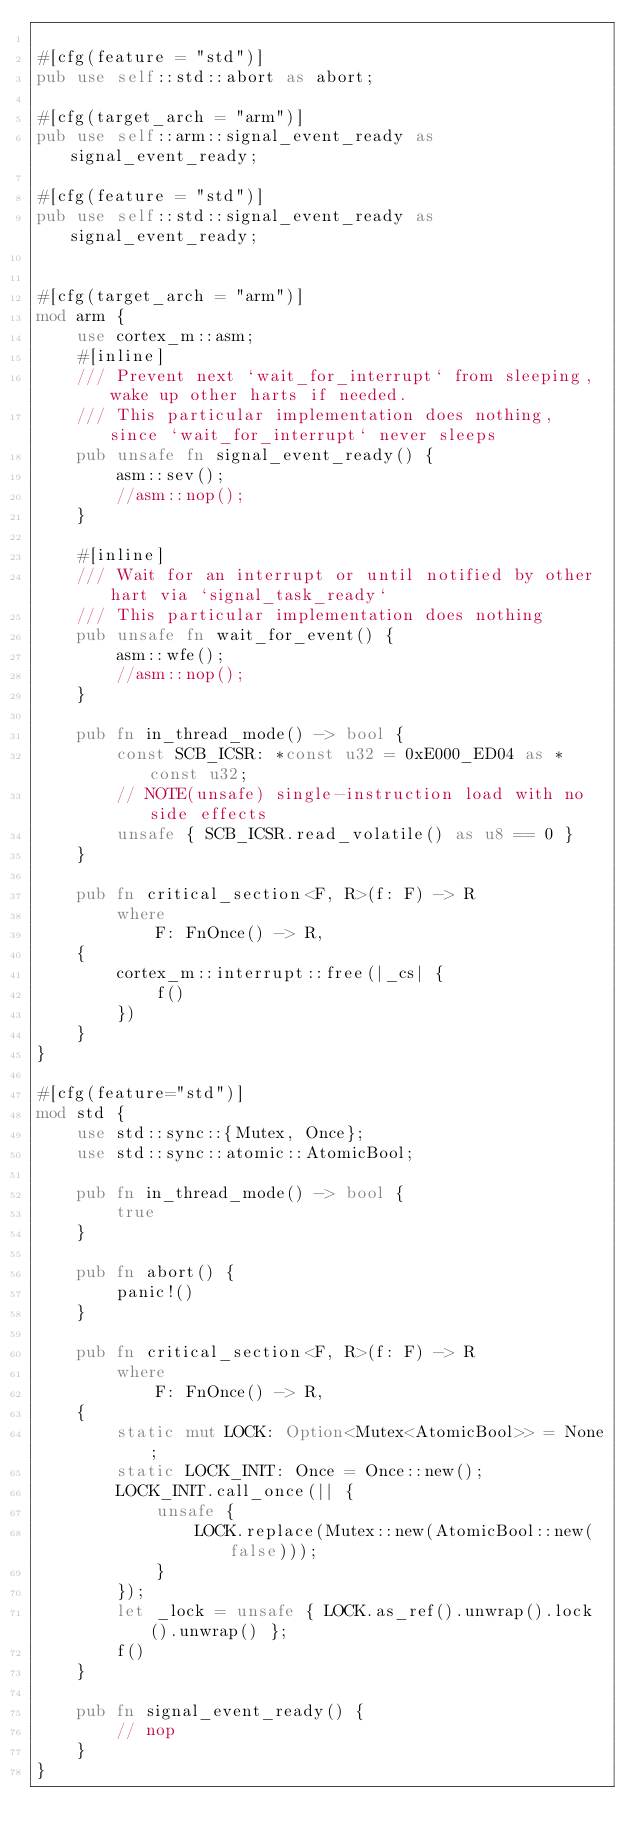<code> <loc_0><loc_0><loc_500><loc_500><_Rust_>
#[cfg(feature = "std")]
pub use self::std::abort as abort;

#[cfg(target_arch = "arm")]
pub use self::arm::signal_event_ready as signal_event_ready;

#[cfg(feature = "std")]
pub use self::std::signal_event_ready as signal_event_ready;


#[cfg(target_arch = "arm")]
mod arm {
    use cortex_m::asm;
    #[inline]
    /// Prevent next `wait_for_interrupt` from sleeping, wake up other harts if needed.
    /// This particular implementation does nothing, since `wait_for_interrupt` never sleeps
    pub unsafe fn signal_event_ready() {
        asm::sev();
        //asm::nop();
    }

    #[inline]
    /// Wait for an interrupt or until notified by other hart via `signal_task_ready`
    /// This particular implementation does nothing
    pub unsafe fn wait_for_event() {
        asm::wfe();
        //asm::nop();
    }

    pub fn in_thread_mode() -> bool {
        const SCB_ICSR: *const u32 = 0xE000_ED04 as *const u32;
        // NOTE(unsafe) single-instruction load with no side effects
        unsafe { SCB_ICSR.read_volatile() as u8 == 0 }
    }

    pub fn critical_section<F, R>(f: F) -> R
        where
            F: FnOnce() -> R,
    {
        cortex_m::interrupt::free(|_cs| {
            f()
        })
    }
}

#[cfg(feature="std")]
mod std {
    use std::sync::{Mutex, Once};
    use std::sync::atomic::AtomicBool;

    pub fn in_thread_mode() -> bool {
        true
    }

    pub fn abort() {
        panic!()
    }

    pub fn critical_section<F, R>(f: F) -> R
        where
            F: FnOnce() -> R,
    {
        static mut LOCK: Option<Mutex<AtomicBool>> = None;
        static LOCK_INIT: Once = Once::new();
        LOCK_INIT.call_once(|| {
            unsafe {
                LOCK.replace(Mutex::new(AtomicBool::new(false)));
            }
        });
        let _lock = unsafe { LOCK.as_ref().unwrap().lock().unwrap() };
        f()
    }

    pub fn signal_event_ready() {
        // nop
    }
}
</code> 